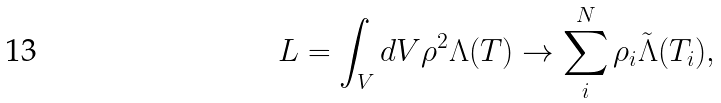<formula> <loc_0><loc_0><loc_500><loc_500>L = \int _ { V } d V \rho ^ { 2 } \Lambda ( T ) \rightarrow \sum _ { i } ^ { N } \rho _ { i } \tilde { \Lambda } ( T _ { i } ) ,</formula> 